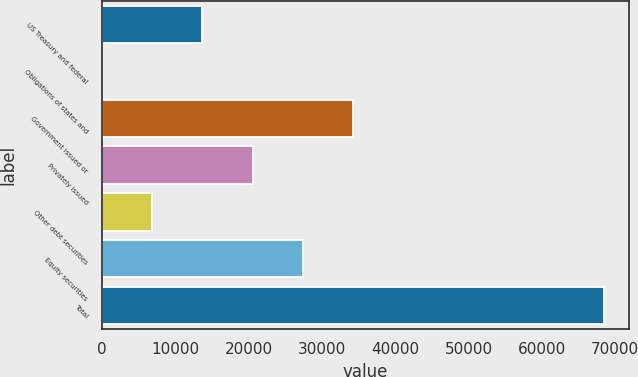<chart> <loc_0><loc_0><loc_500><loc_500><bar_chart><fcel>US Treasury and federal<fcel>Obligations of states and<fcel>Government issued or<fcel>Privately issued<fcel>Other debt securities<fcel>Equity securities<fcel>Total<nl><fcel>13704.8<fcel>8<fcel>34250<fcel>20553.2<fcel>6856.4<fcel>27401.6<fcel>68492<nl></chart> 